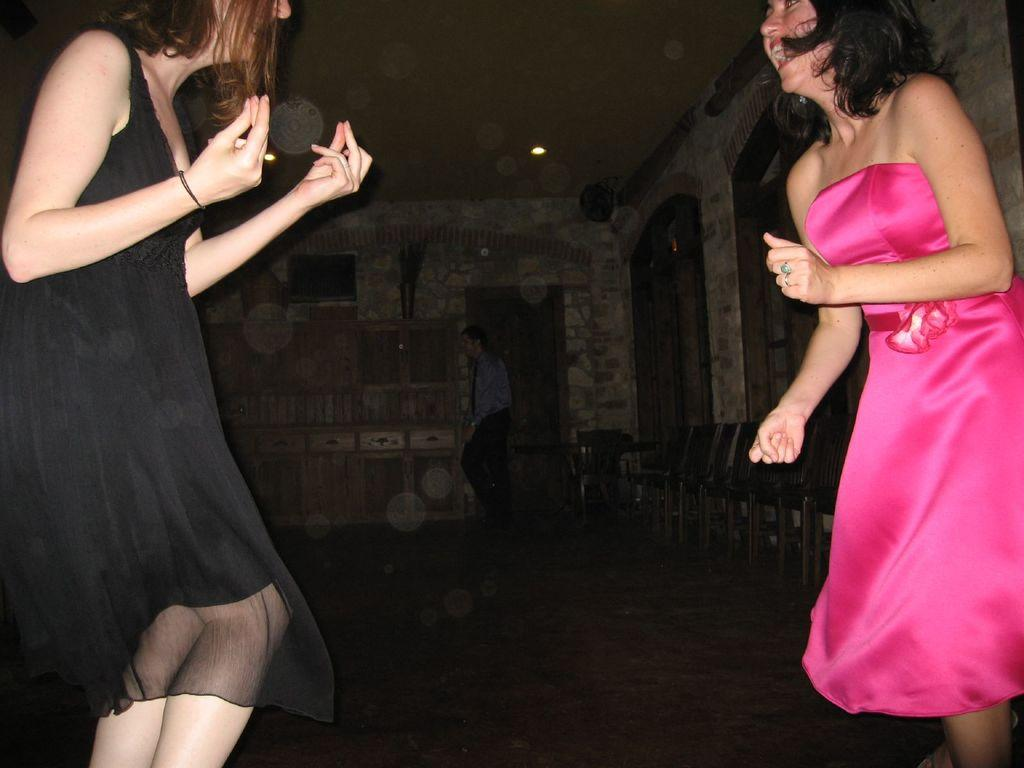How many people are in the image? There are two women in the image. What are the women wearing? The women are wearing clothes. What expression do the women have? The women are smiling. What activity are the women engaged in? It appears that the women are dancing. What type of furniture is present in the image? There are chairs in the image. What is the color of the background in the image? The background of the image is dark. What type of sink can be seen in the image? There is no sink present in the image. What is the air quality like in the image? The image does not provide information about the air quality. 